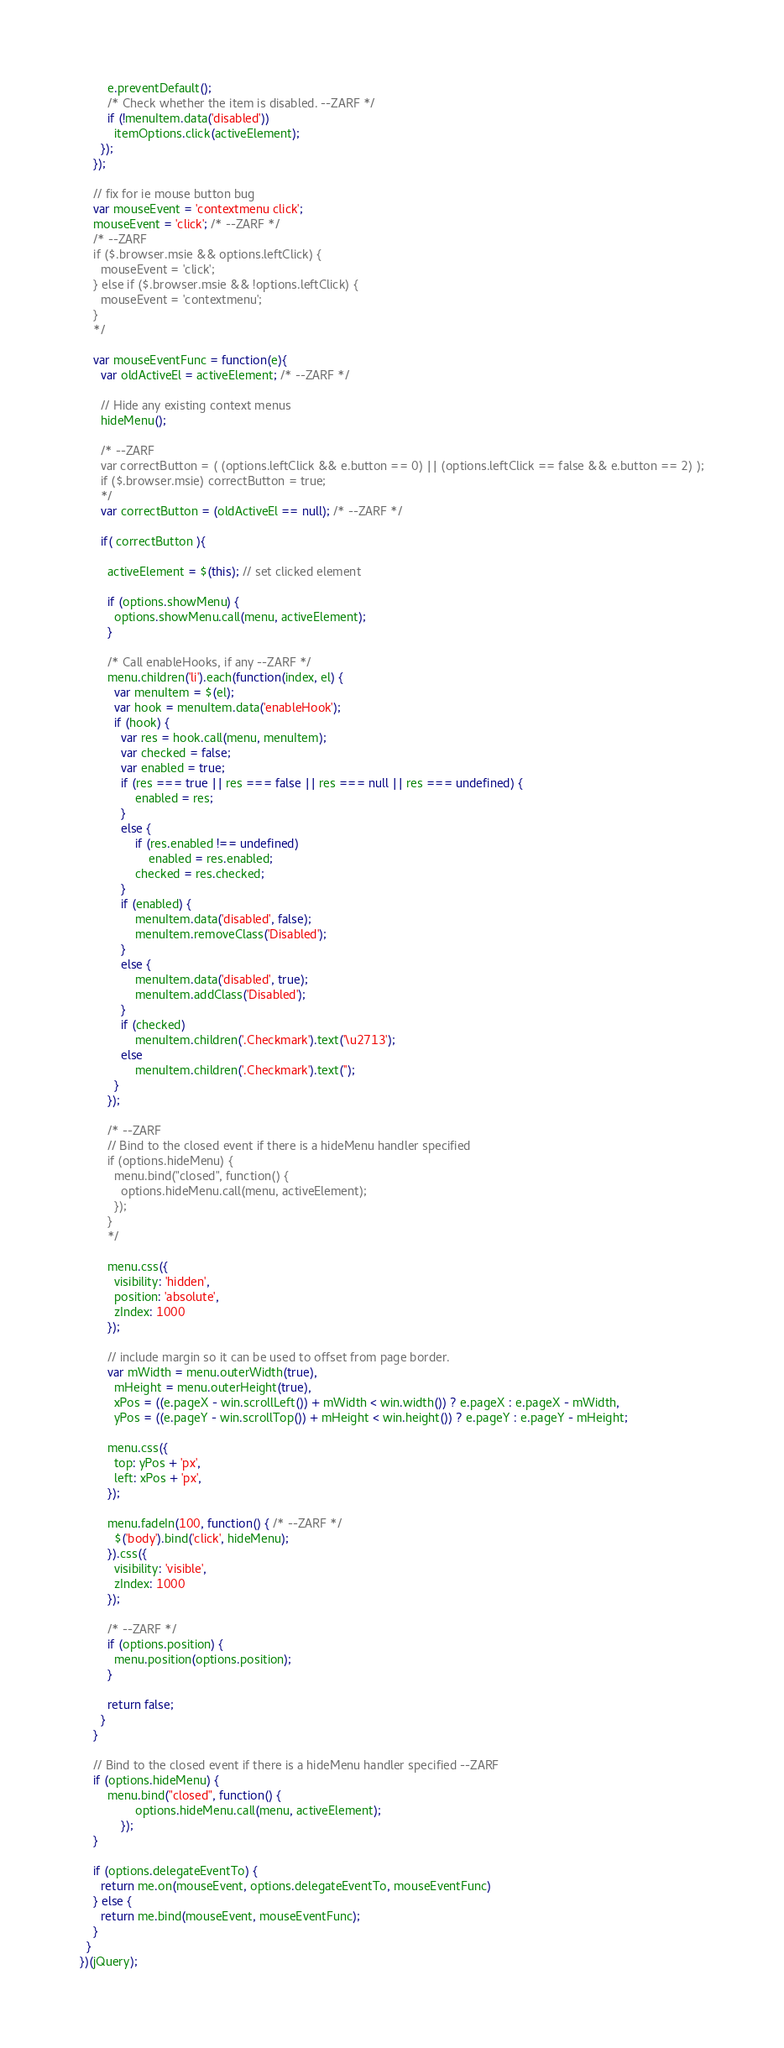Convert code to text. <code><loc_0><loc_0><loc_500><loc_500><_JavaScript_>        e.preventDefault();
        /* Check whether the item is disabled. --ZARF */
        if (!menuItem.data('disabled'))
          itemOptions.click(activeElement);
      });
    });

    // fix for ie mouse button bug
    var mouseEvent = 'contextmenu click';
    mouseEvent = 'click'; /* --ZARF */
    /* --ZARF
    if ($.browser.msie && options.leftClick) {
      mouseEvent = 'click';
    } else if ($.browser.msie && !options.leftClick) {
      mouseEvent = 'contextmenu';
    }
    */

    var mouseEventFunc = function(e){
      var oldActiveEl = activeElement; /* --ZARF */

      // Hide any existing context menus
      hideMenu();

      /* --ZARF
      var correctButton = ( (options.leftClick && e.button == 0) || (options.leftClick == false && e.button == 2) );
      if ($.browser.msie) correctButton = true;
      */
      var correctButton = (oldActiveEl == null); /* --ZARF */

      if( correctButton ){

        activeElement = $(this); // set clicked element

        if (options.showMenu) {
          options.showMenu.call(menu, activeElement);
        }

        /* Call enableHooks, if any --ZARF */
        menu.children('li').each(function(index, el) {
          var menuItem = $(el);
          var hook = menuItem.data('enableHook');
          if (hook) {
            var res = hook.call(menu, menuItem);
            var checked = false;
            var enabled = true;
            if (res === true || res === false || res === null || res === undefined) {
                enabled = res;
            }
            else {
                if (res.enabled !== undefined)
                    enabled = res.enabled;
                checked = res.checked;
            }
            if (enabled) {
                menuItem.data('disabled', false);
                menuItem.removeClass('Disabled');
            }
            else {
                menuItem.data('disabled', true);
                menuItem.addClass('Disabled');
            }
            if (checked)
                menuItem.children('.Checkmark').text('\u2713');
            else
                menuItem.children('.Checkmark').text('');
          }
        });
        
        /* --ZARF
        // Bind to the closed event if there is a hideMenu handler specified
        if (options.hideMenu) {
          menu.bind("closed", function() {
            options.hideMenu.call(menu, activeElement);
          });
        }
        */

        menu.css({
          visibility: 'hidden',
          position: 'absolute',
          zIndex: 1000
        });

        // include margin so it can be used to offset from page border.
        var mWidth = menu.outerWidth(true),
          mHeight = menu.outerHeight(true),
          xPos = ((e.pageX - win.scrollLeft()) + mWidth < win.width()) ? e.pageX : e.pageX - mWidth,
          yPos = ((e.pageY - win.scrollTop()) + mHeight < win.height()) ? e.pageY : e.pageY - mHeight;

        menu.css({
          top: yPos + 'px',
          left: xPos + 'px',
        });

        menu.fadeIn(100, function() { /* --ZARF */
          $('body').bind('click', hideMenu);
        }).css({
          visibility: 'visible',
          zIndex: 1000
        });

        /* --ZARF */
        if (options.position) {
          menu.position(options.position);
        }

        return false;
      }
    }

    // Bind to the closed event if there is a hideMenu handler specified --ZARF
    if (options.hideMenu) {
        menu.bind("closed", function() {
                options.hideMenu.call(menu, activeElement);
            });
    }

    if (options.delegateEventTo) {
      return me.on(mouseEvent, options.delegateEventTo, mouseEventFunc)
    } else {
      return me.bind(mouseEvent, mouseEventFunc);
    }
  }
})(jQuery);

</code> 